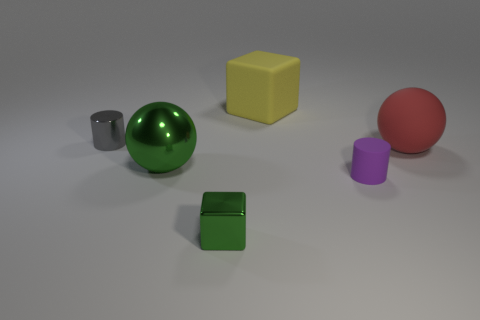Is there any other thing that is the same color as the metallic sphere?
Your answer should be compact. Yes. Does the tiny green thing have the same shape as the rubber object that is behind the matte sphere?
Your response must be concise. Yes. What color is the large ball that is to the left of the sphere right of the large rubber thing behind the tiny gray thing?
Your answer should be very brief. Green. There is a large thing to the right of the yellow matte cube; is its shape the same as the small purple rubber thing?
Your response must be concise. No. What material is the large red sphere?
Offer a terse response. Rubber. What shape is the large rubber object that is behind the large matte object in front of the cube that is behind the large green ball?
Your answer should be compact. Cube. How many other objects are there of the same shape as the large metal object?
Give a very brief answer. 1. There is a rubber block; is it the same color as the tiny shiny thing to the left of the metallic cube?
Your answer should be very brief. No. What number of big gray metal blocks are there?
Ensure brevity in your answer.  0. What number of objects are large red metal objects or small cylinders?
Offer a very short reply. 2. 